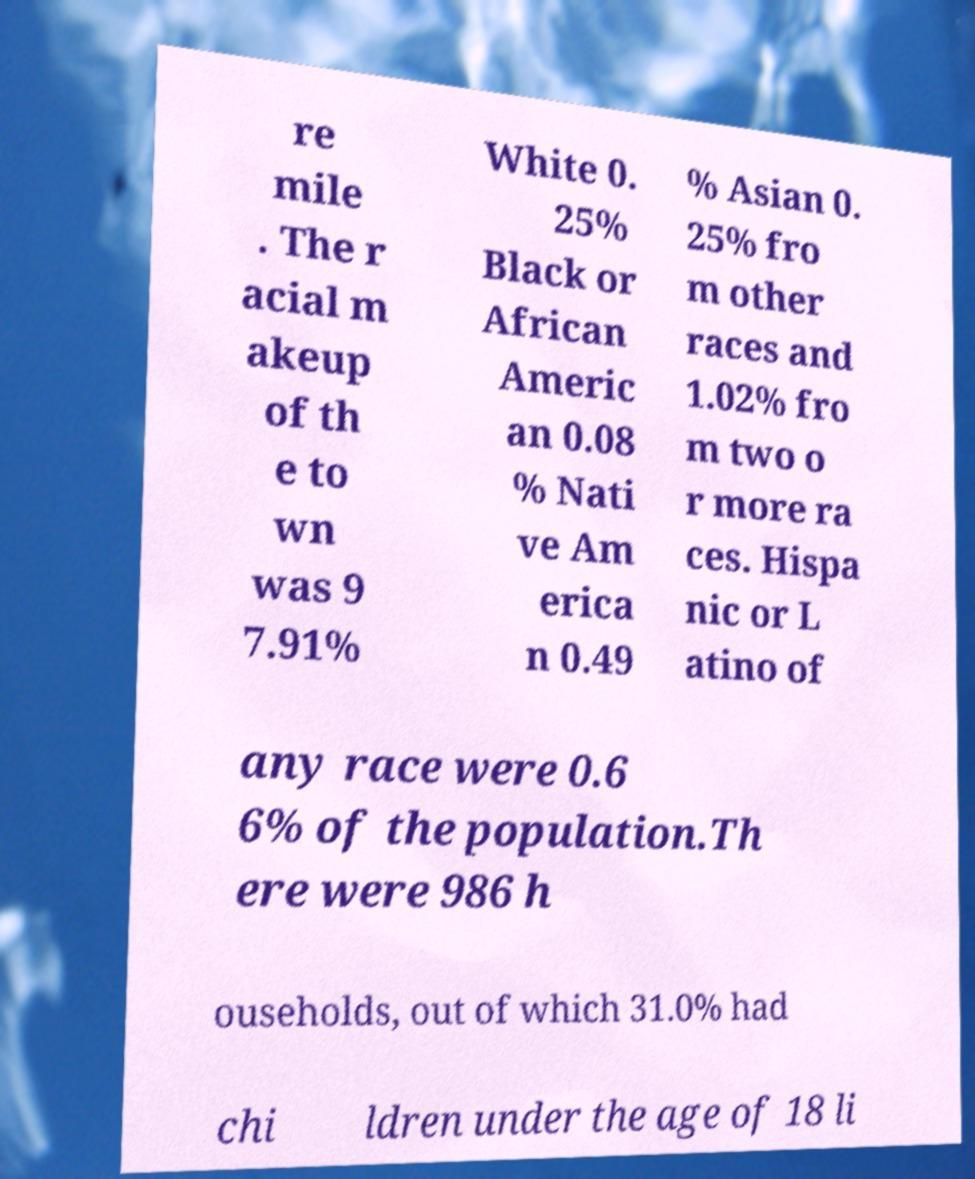Please read and relay the text visible in this image. What does it say? re mile . The r acial m akeup of th e to wn was 9 7.91% White 0. 25% Black or African Americ an 0.08 % Nati ve Am erica n 0.49 % Asian 0. 25% fro m other races and 1.02% fro m two o r more ra ces. Hispa nic or L atino of any race were 0.6 6% of the population.Th ere were 986 h ouseholds, out of which 31.0% had chi ldren under the age of 18 li 